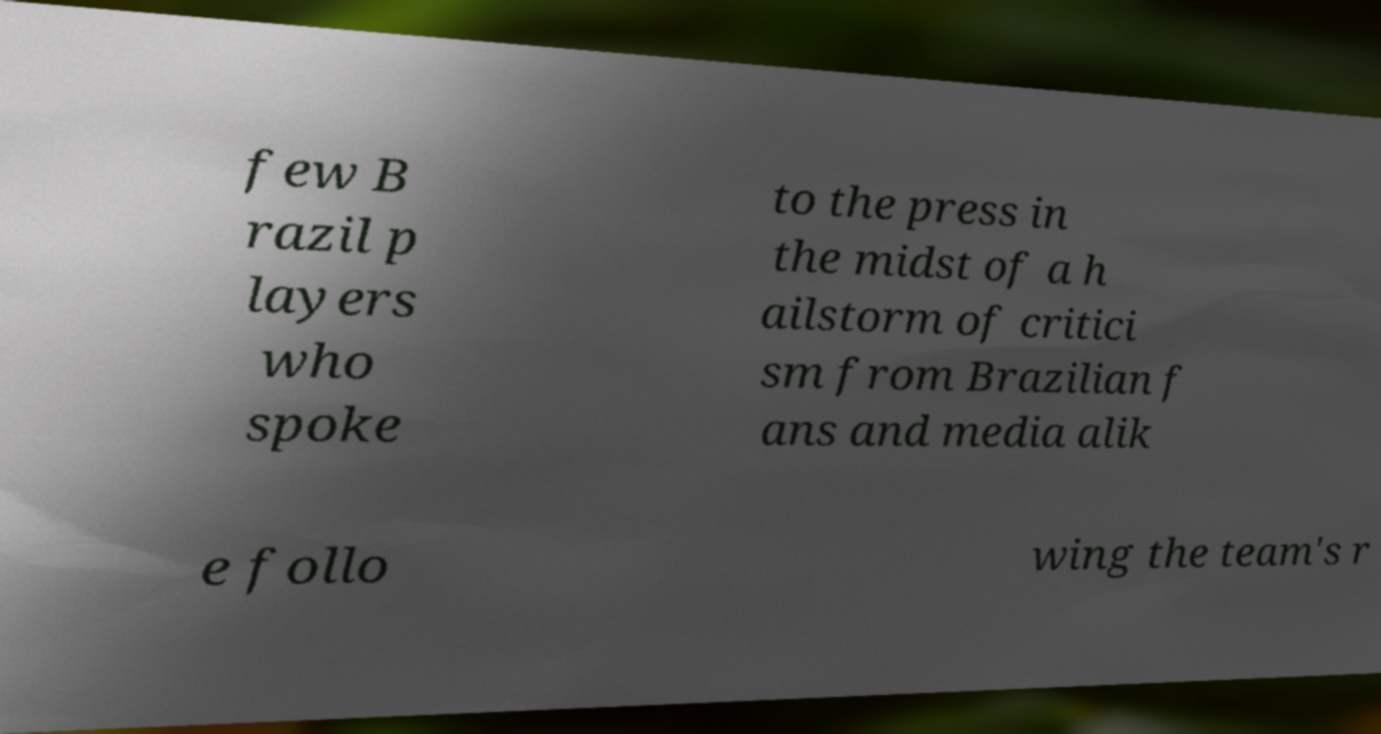For documentation purposes, I need the text within this image transcribed. Could you provide that? few B razil p layers who spoke to the press in the midst of a h ailstorm of critici sm from Brazilian f ans and media alik e follo wing the team's r 